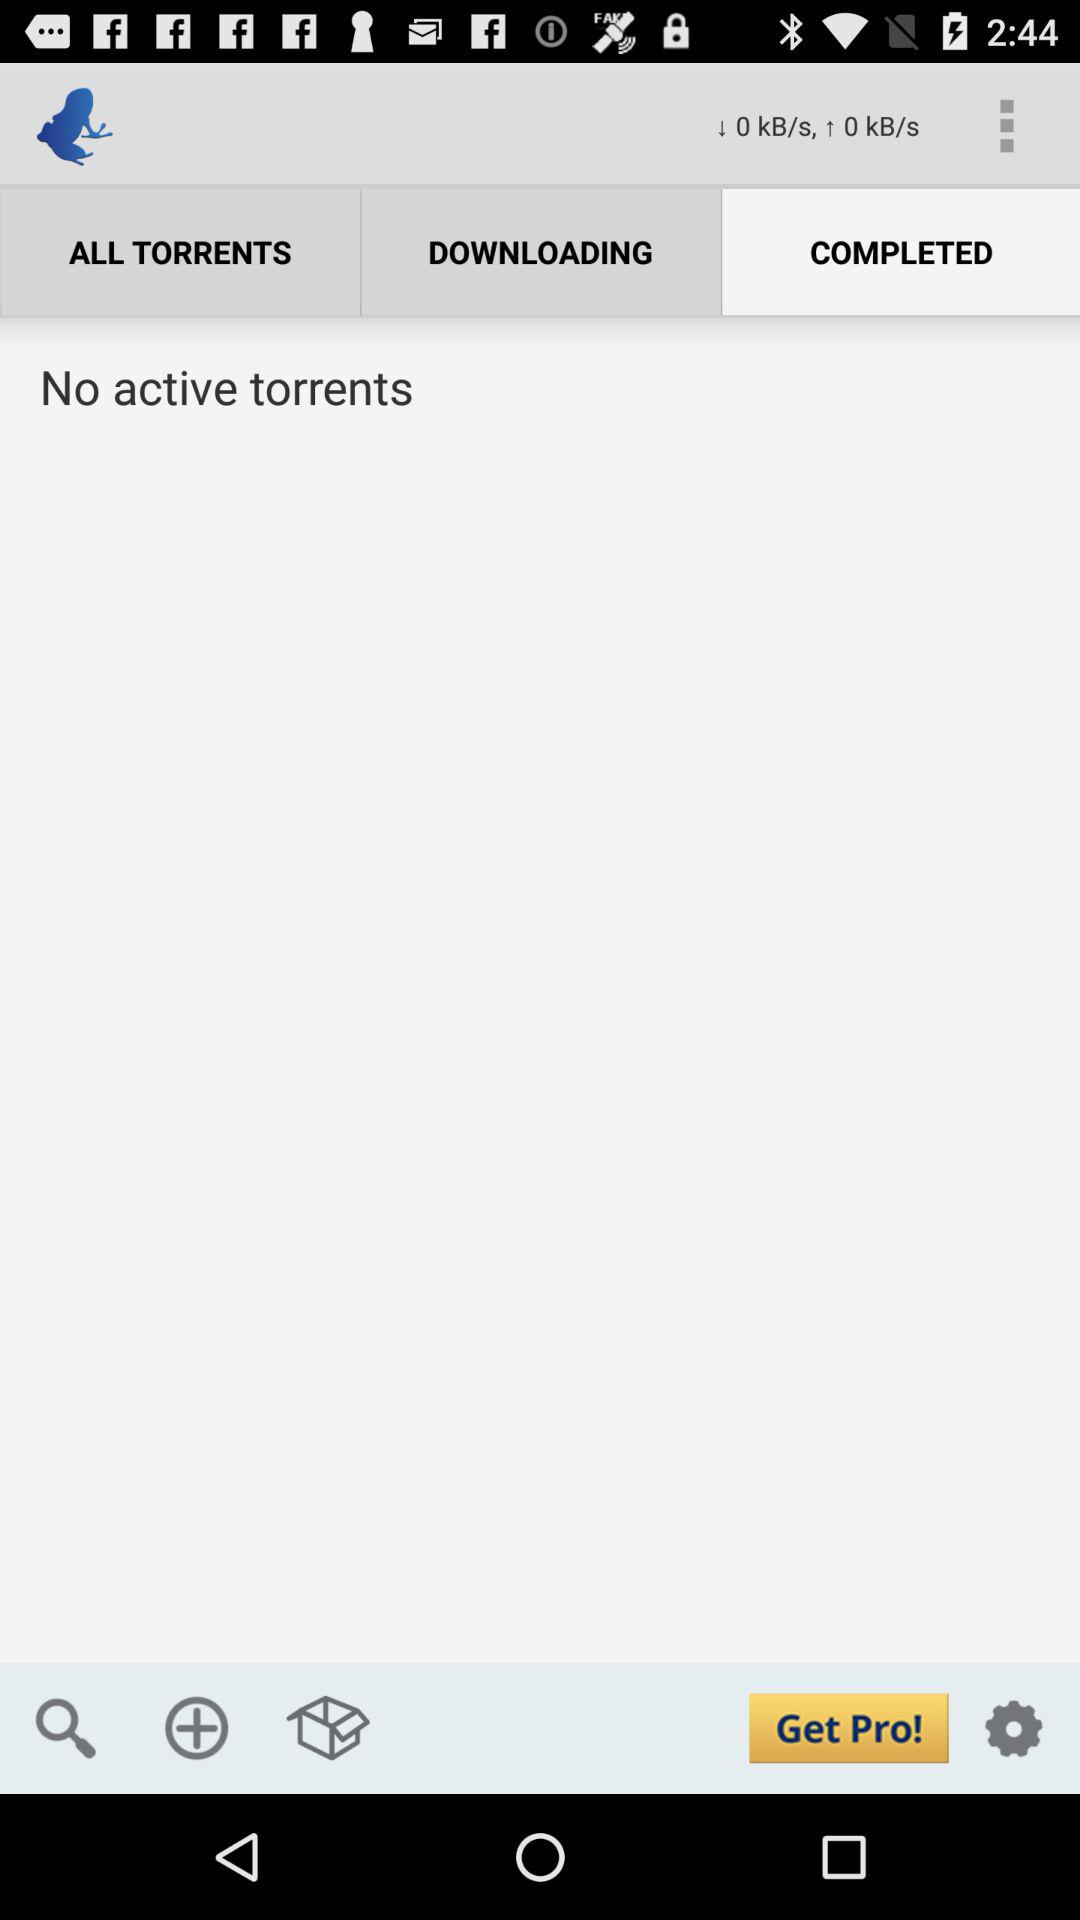Which tab is selected? The 'COMPLETED' tab is currently selected, as indicated by its distinct highlighting compared to the 'ALL TORRENTS' and 'DOWNLOADING' tabs. This visual cue usually signifies that the tab is active and its corresponding content is visible on the screen, which in this case indicates there are no active torrents in this section. 